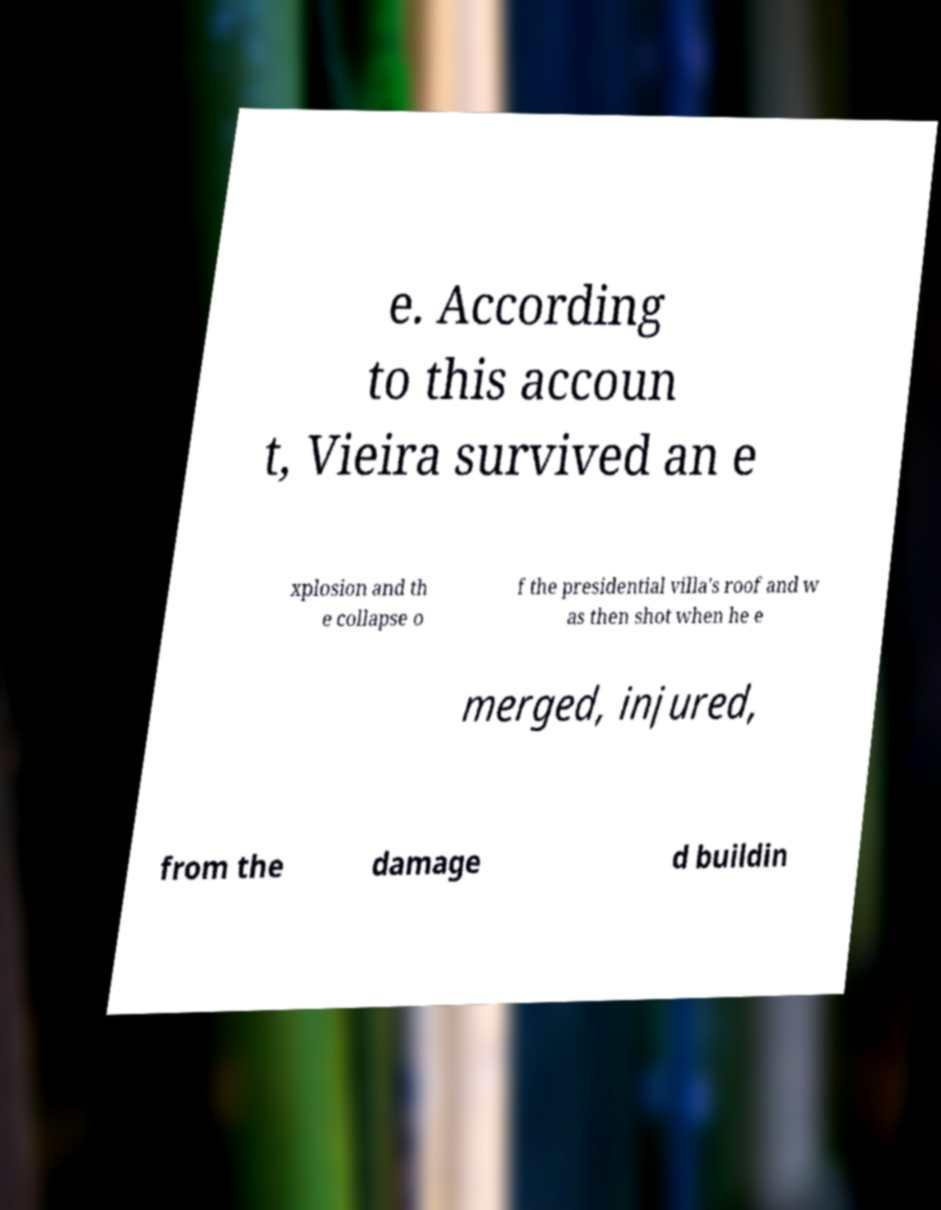Could you extract and type out the text from this image? e. According to this accoun t, Vieira survived an e xplosion and th e collapse o f the presidential villa's roof and w as then shot when he e merged, injured, from the damage d buildin 